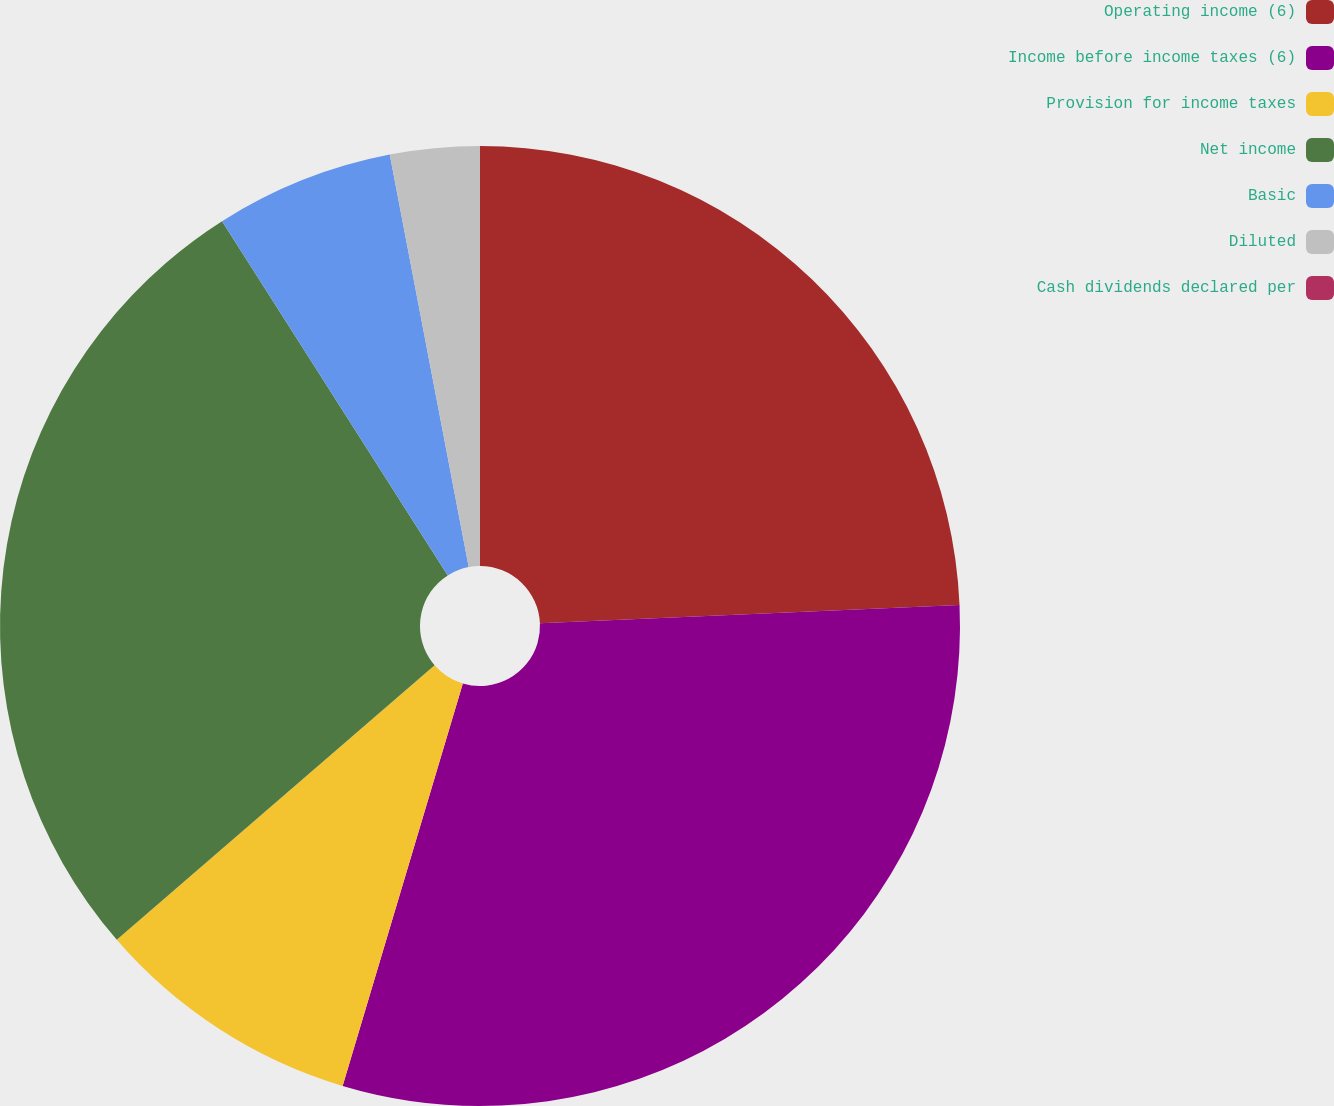Convert chart. <chart><loc_0><loc_0><loc_500><loc_500><pie_chart><fcel>Operating income (6)<fcel>Income before income taxes (6)<fcel>Provision for income taxes<fcel>Net income<fcel>Basic<fcel>Diluted<fcel>Cash dividends declared per<nl><fcel>24.3%<fcel>30.32%<fcel>9.04%<fcel>27.31%<fcel>6.02%<fcel>3.01%<fcel>0.0%<nl></chart> 